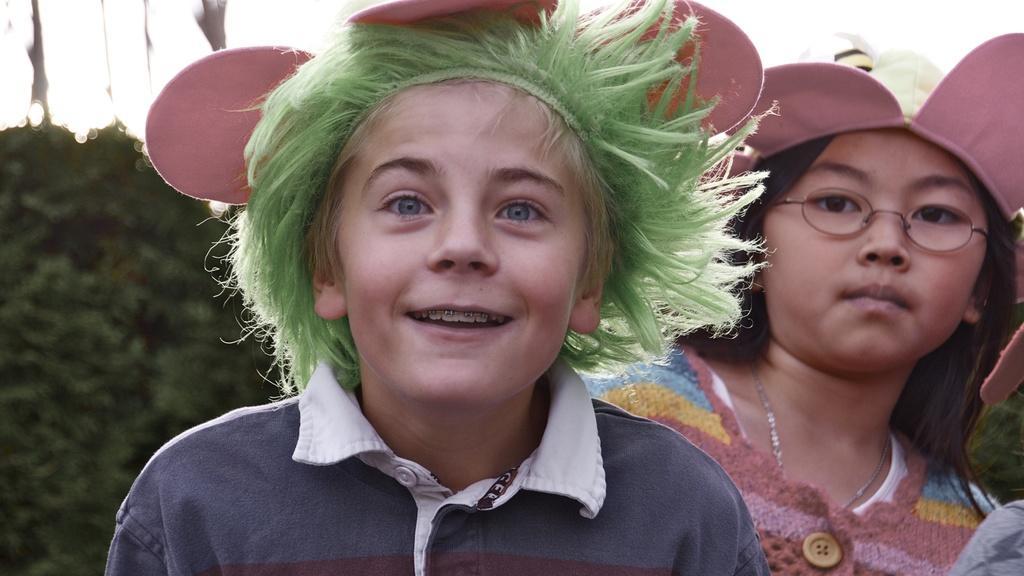Could you give a brief overview of what you see in this image? In the picture we can see two girls are standing one behind the other one girl is smiling and they are with decorated cap and behind them we can see some bushes. 